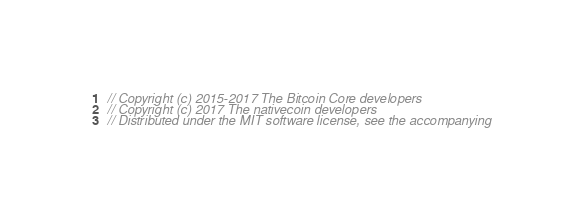<code> <loc_0><loc_0><loc_500><loc_500><_C_>// Copyright (c) 2015-2017 The Bitcoin Core developers
// Copyright (c) 2017 The nativecoin developers
// Distributed under the MIT software license, see the accompanying</code> 